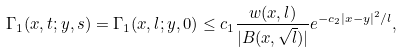Convert formula to latex. <formula><loc_0><loc_0><loc_500><loc_500>\Gamma _ { 1 } ( x , t ; y , s ) = \Gamma _ { 1 } ( x , l ; y , 0 ) \leq c _ { 1 } \frac { w ( x , l ) } { | B ( x , \sqrt { l } ) | } e ^ { - c _ { 2 } | x - y | ^ { 2 } / l } ,</formula> 